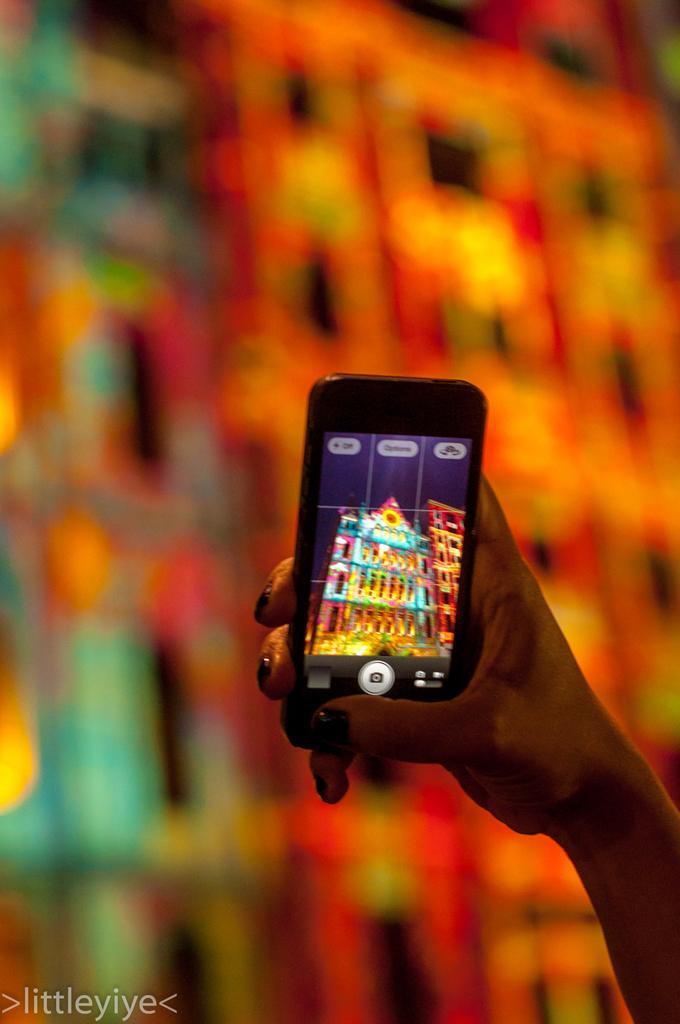In one or two sentences, can you explain what this image depicts? In the image we can see there is a woman holding mobile phone in her hand and there is a picture of a building in it. Behind the image is little blurry. 